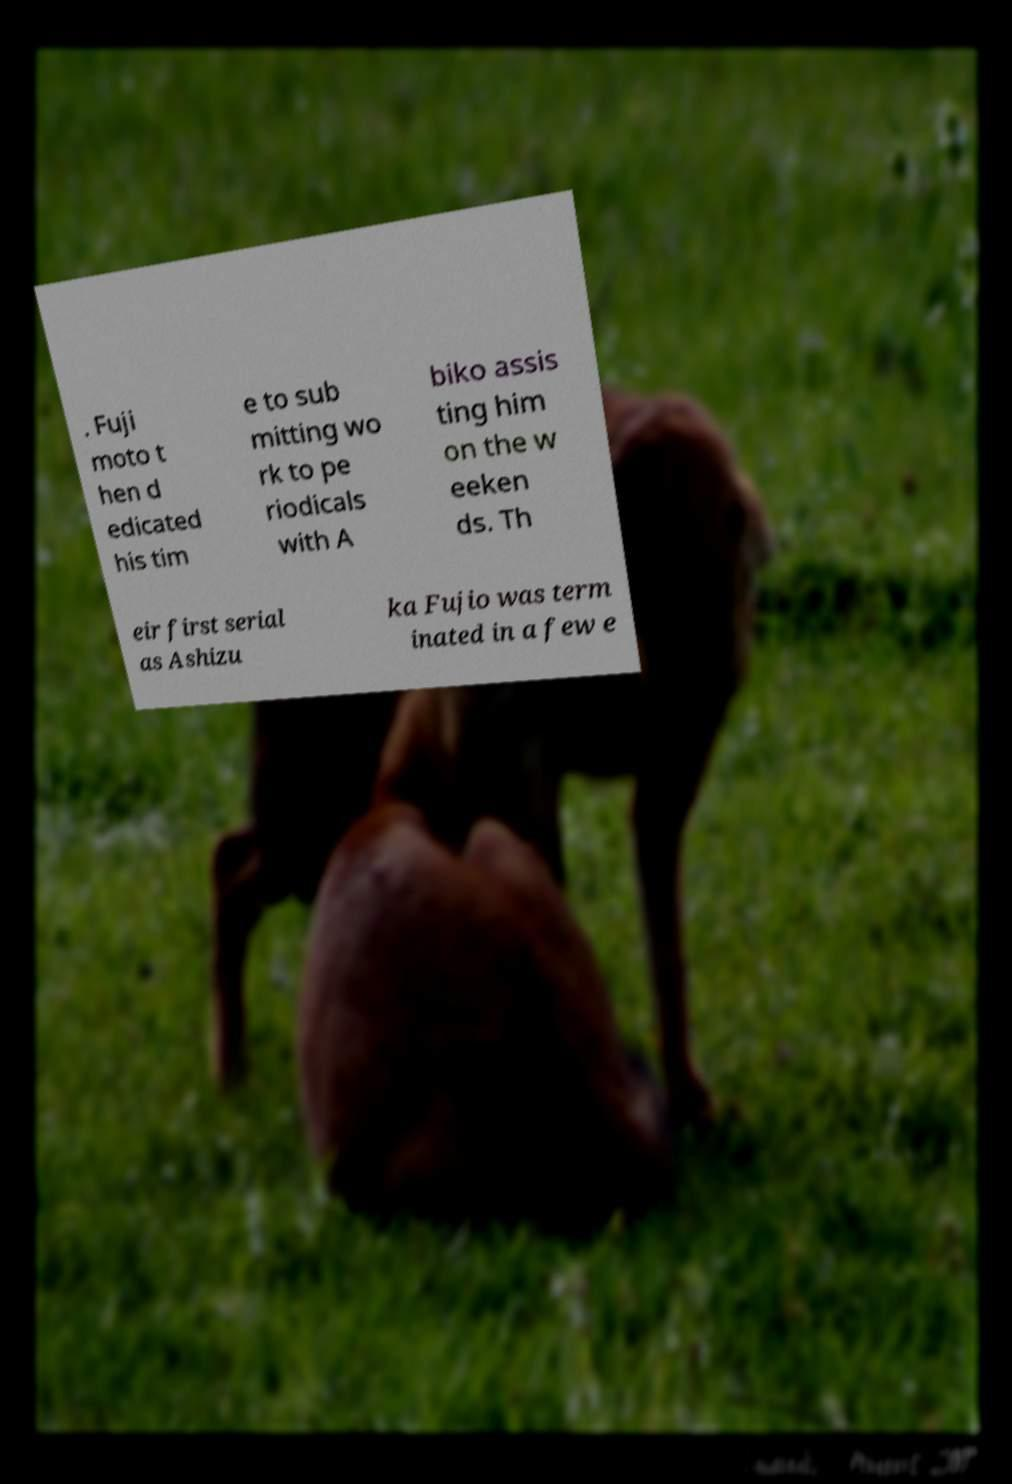There's text embedded in this image that I need extracted. Can you transcribe it verbatim? . Fuji moto t hen d edicated his tim e to sub mitting wo rk to pe riodicals with A biko assis ting him on the w eeken ds. Th eir first serial as Ashizu ka Fujio was term inated in a few e 